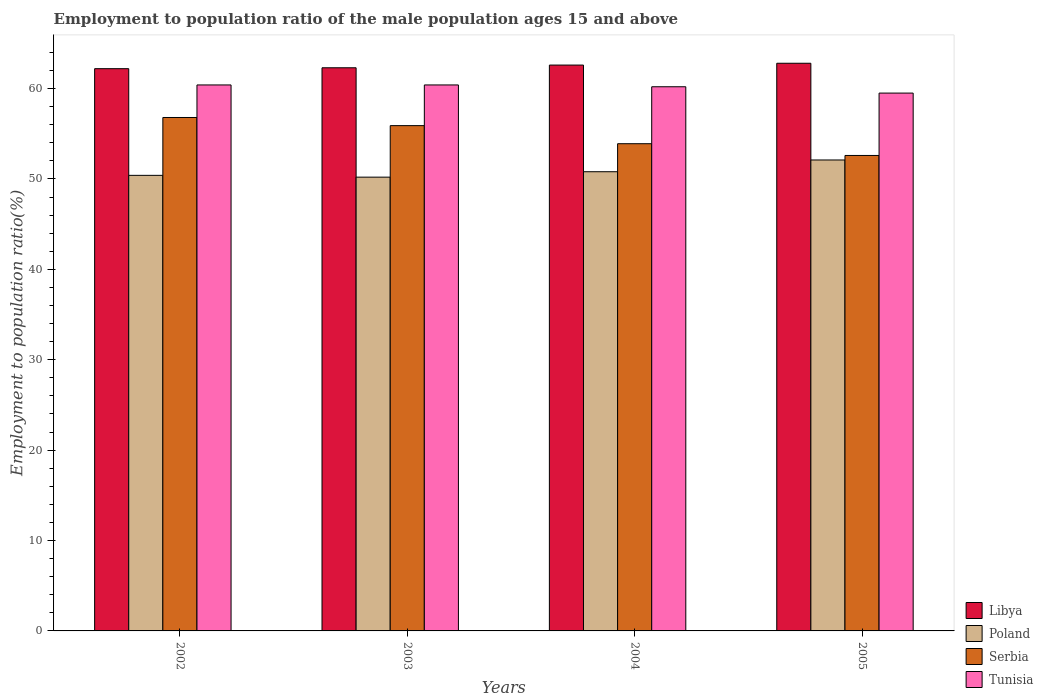How many groups of bars are there?
Offer a terse response. 4. Are the number of bars per tick equal to the number of legend labels?
Make the answer very short. Yes. Are the number of bars on each tick of the X-axis equal?
Provide a short and direct response. Yes. What is the label of the 4th group of bars from the left?
Your response must be concise. 2005. What is the employment to population ratio in Tunisia in 2004?
Offer a very short reply. 60.2. Across all years, what is the maximum employment to population ratio in Tunisia?
Your answer should be very brief. 60.4. Across all years, what is the minimum employment to population ratio in Serbia?
Give a very brief answer. 52.6. What is the total employment to population ratio in Tunisia in the graph?
Your answer should be compact. 240.5. What is the difference between the employment to population ratio in Serbia in 2002 and that in 2005?
Provide a succinct answer. 4.2. What is the difference between the employment to population ratio in Libya in 2002 and the employment to population ratio in Tunisia in 2004?
Give a very brief answer. 2. What is the average employment to population ratio in Libya per year?
Ensure brevity in your answer.  62.47. In the year 2004, what is the difference between the employment to population ratio in Libya and employment to population ratio in Tunisia?
Provide a short and direct response. 2.4. In how many years, is the employment to population ratio in Serbia greater than 62 %?
Make the answer very short. 0. What is the ratio of the employment to population ratio in Serbia in 2003 to that in 2004?
Keep it short and to the point. 1.04. Is the employment to population ratio in Libya in 2002 less than that in 2005?
Provide a succinct answer. Yes. Is the difference between the employment to population ratio in Libya in 2002 and 2005 greater than the difference between the employment to population ratio in Tunisia in 2002 and 2005?
Give a very brief answer. No. What is the difference between the highest and the lowest employment to population ratio in Tunisia?
Offer a very short reply. 0.9. In how many years, is the employment to population ratio in Poland greater than the average employment to population ratio in Poland taken over all years?
Offer a terse response. 1. Is the sum of the employment to population ratio in Libya in 2002 and 2004 greater than the maximum employment to population ratio in Tunisia across all years?
Make the answer very short. Yes. What does the 2nd bar from the left in 2005 represents?
Keep it short and to the point. Poland. What does the 2nd bar from the right in 2002 represents?
Your answer should be very brief. Serbia. How many bars are there?
Offer a terse response. 16. Are all the bars in the graph horizontal?
Your response must be concise. No. How many years are there in the graph?
Provide a short and direct response. 4. Are the values on the major ticks of Y-axis written in scientific E-notation?
Your answer should be compact. No. Does the graph contain any zero values?
Ensure brevity in your answer.  No. Does the graph contain grids?
Your answer should be very brief. No. How are the legend labels stacked?
Offer a very short reply. Vertical. What is the title of the graph?
Provide a succinct answer. Employment to population ratio of the male population ages 15 and above. Does "Finland" appear as one of the legend labels in the graph?
Provide a succinct answer. No. What is the label or title of the X-axis?
Give a very brief answer. Years. What is the label or title of the Y-axis?
Give a very brief answer. Employment to population ratio(%). What is the Employment to population ratio(%) in Libya in 2002?
Your response must be concise. 62.2. What is the Employment to population ratio(%) in Poland in 2002?
Ensure brevity in your answer.  50.4. What is the Employment to population ratio(%) of Serbia in 2002?
Make the answer very short. 56.8. What is the Employment to population ratio(%) of Tunisia in 2002?
Make the answer very short. 60.4. What is the Employment to population ratio(%) in Libya in 2003?
Ensure brevity in your answer.  62.3. What is the Employment to population ratio(%) of Poland in 2003?
Make the answer very short. 50.2. What is the Employment to population ratio(%) of Serbia in 2003?
Ensure brevity in your answer.  55.9. What is the Employment to population ratio(%) of Tunisia in 2003?
Provide a short and direct response. 60.4. What is the Employment to population ratio(%) in Libya in 2004?
Your answer should be compact. 62.6. What is the Employment to population ratio(%) of Poland in 2004?
Offer a very short reply. 50.8. What is the Employment to population ratio(%) in Serbia in 2004?
Offer a terse response. 53.9. What is the Employment to population ratio(%) of Tunisia in 2004?
Offer a terse response. 60.2. What is the Employment to population ratio(%) in Libya in 2005?
Your answer should be compact. 62.8. What is the Employment to population ratio(%) in Poland in 2005?
Make the answer very short. 52.1. What is the Employment to population ratio(%) in Serbia in 2005?
Offer a terse response. 52.6. What is the Employment to population ratio(%) of Tunisia in 2005?
Provide a short and direct response. 59.5. Across all years, what is the maximum Employment to population ratio(%) in Libya?
Offer a very short reply. 62.8. Across all years, what is the maximum Employment to population ratio(%) of Poland?
Your answer should be very brief. 52.1. Across all years, what is the maximum Employment to population ratio(%) of Serbia?
Offer a terse response. 56.8. Across all years, what is the maximum Employment to population ratio(%) of Tunisia?
Provide a succinct answer. 60.4. Across all years, what is the minimum Employment to population ratio(%) in Libya?
Your response must be concise. 62.2. Across all years, what is the minimum Employment to population ratio(%) in Poland?
Give a very brief answer. 50.2. Across all years, what is the minimum Employment to population ratio(%) of Serbia?
Offer a terse response. 52.6. Across all years, what is the minimum Employment to population ratio(%) in Tunisia?
Make the answer very short. 59.5. What is the total Employment to population ratio(%) of Libya in the graph?
Your answer should be compact. 249.9. What is the total Employment to population ratio(%) of Poland in the graph?
Your response must be concise. 203.5. What is the total Employment to population ratio(%) in Serbia in the graph?
Keep it short and to the point. 219.2. What is the total Employment to population ratio(%) of Tunisia in the graph?
Make the answer very short. 240.5. What is the difference between the Employment to population ratio(%) of Poland in 2002 and that in 2003?
Keep it short and to the point. 0.2. What is the difference between the Employment to population ratio(%) of Libya in 2002 and that in 2004?
Provide a short and direct response. -0.4. What is the difference between the Employment to population ratio(%) in Libya in 2002 and that in 2005?
Your response must be concise. -0.6. What is the difference between the Employment to population ratio(%) of Poland in 2002 and that in 2005?
Make the answer very short. -1.7. What is the difference between the Employment to population ratio(%) in Libya in 2003 and that in 2004?
Offer a terse response. -0.3. What is the difference between the Employment to population ratio(%) in Poland in 2003 and that in 2004?
Provide a short and direct response. -0.6. What is the difference between the Employment to population ratio(%) of Libya in 2003 and that in 2005?
Provide a succinct answer. -0.5. What is the difference between the Employment to population ratio(%) in Poland in 2003 and that in 2005?
Your answer should be very brief. -1.9. What is the difference between the Employment to population ratio(%) of Serbia in 2003 and that in 2005?
Provide a short and direct response. 3.3. What is the difference between the Employment to population ratio(%) in Libya in 2002 and the Employment to population ratio(%) in Poland in 2003?
Give a very brief answer. 12. What is the difference between the Employment to population ratio(%) of Libya in 2002 and the Employment to population ratio(%) of Serbia in 2003?
Offer a terse response. 6.3. What is the difference between the Employment to population ratio(%) in Libya in 2002 and the Employment to population ratio(%) in Tunisia in 2003?
Provide a short and direct response. 1.8. What is the difference between the Employment to population ratio(%) of Serbia in 2002 and the Employment to population ratio(%) of Tunisia in 2003?
Keep it short and to the point. -3.6. What is the difference between the Employment to population ratio(%) of Libya in 2002 and the Employment to population ratio(%) of Poland in 2004?
Give a very brief answer. 11.4. What is the difference between the Employment to population ratio(%) of Libya in 2002 and the Employment to population ratio(%) of Tunisia in 2004?
Keep it short and to the point. 2. What is the difference between the Employment to population ratio(%) in Serbia in 2002 and the Employment to population ratio(%) in Tunisia in 2004?
Make the answer very short. -3.4. What is the difference between the Employment to population ratio(%) of Libya in 2002 and the Employment to population ratio(%) of Serbia in 2005?
Provide a succinct answer. 9.6. What is the difference between the Employment to population ratio(%) in Libya in 2002 and the Employment to population ratio(%) in Tunisia in 2005?
Provide a short and direct response. 2.7. What is the difference between the Employment to population ratio(%) in Libya in 2003 and the Employment to population ratio(%) in Serbia in 2004?
Your response must be concise. 8.4. What is the difference between the Employment to population ratio(%) in Libya in 2003 and the Employment to population ratio(%) in Tunisia in 2004?
Offer a terse response. 2.1. What is the difference between the Employment to population ratio(%) in Poland in 2003 and the Employment to population ratio(%) in Serbia in 2004?
Provide a short and direct response. -3.7. What is the difference between the Employment to population ratio(%) in Poland in 2003 and the Employment to population ratio(%) in Tunisia in 2004?
Provide a short and direct response. -10. What is the difference between the Employment to population ratio(%) in Serbia in 2003 and the Employment to population ratio(%) in Tunisia in 2004?
Provide a short and direct response. -4.3. What is the difference between the Employment to population ratio(%) in Libya in 2003 and the Employment to population ratio(%) in Tunisia in 2005?
Your response must be concise. 2.8. What is the difference between the Employment to population ratio(%) in Poland in 2003 and the Employment to population ratio(%) in Serbia in 2005?
Your response must be concise. -2.4. What is the difference between the Employment to population ratio(%) in Poland in 2003 and the Employment to population ratio(%) in Tunisia in 2005?
Give a very brief answer. -9.3. What is the difference between the Employment to population ratio(%) in Libya in 2004 and the Employment to population ratio(%) in Poland in 2005?
Offer a very short reply. 10.5. What is the difference between the Employment to population ratio(%) in Libya in 2004 and the Employment to population ratio(%) in Serbia in 2005?
Provide a short and direct response. 10. What is the difference between the Employment to population ratio(%) in Serbia in 2004 and the Employment to population ratio(%) in Tunisia in 2005?
Your answer should be compact. -5.6. What is the average Employment to population ratio(%) in Libya per year?
Ensure brevity in your answer.  62.48. What is the average Employment to population ratio(%) of Poland per year?
Your response must be concise. 50.88. What is the average Employment to population ratio(%) in Serbia per year?
Provide a short and direct response. 54.8. What is the average Employment to population ratio(%) in Tunisia per year?
Your response must be concise. 60.12. In the year 2002, what is the difference between the Employment to population ratio(%) in Libya and Employment to population ratio(%) in Tunisia?
Provide a short and direct response. 1.8. In the year 2002, what is the difference between the Employment to population ratio(%) of Poland and Employment to population ratio(%) of Tunisia?
Make the answer very short. -10. In the year 2002, what is the difference between the Employment to population ratio(%) in Serbia and Employment to population ratio(%) in Tunisia?
Offer a very short reply. -3.6. In the year 2003, what is the difference between the Employment to population ratio(%) of Libya and Employment to population ratio(%) of Poland?
Give a very brief answer. 12.1. In the year 2003, what is the difference between the Employment to population ratio(%) in Libya and Employment to population ratio(%) in Serbia?
Your response must be concise. 6.4. In the year 2003, what is the difference between the Employment to population ratio(%) of Libya and Employment to population ratio(%) of Tunisia?
Your answer should be compact. 1.9. In the year 2003, what is the difference between the Employment to population ratio(%) of Poland and Employment to population ratio(%) of Tunisia?
Offer a terse response. -10.2. In the year 2004, what is the difference between the Employment to population ratio(%) in Libya and Employment to population ratio(%) in Serbia?
Offer a very short reply. 8.7. In the year 2004, what is the difference between the Employment to population ratio(%) in Libya and Employment to population ratio(%) in Tunisia?
Make the answer very short. 2.4. In the year 2005, what is the difference between the Employment to population ratio(%) of Libya and Employment to population ratio(%) of Poland?
Offer a terse response. 10.7. What is the ratio of the Employment to population ratio(%) of Poland in 2002 to that in 2003?
Make the answer very short. 1. What is the ratio of the Employment to population ratio(%) of Serbia in 2002 to that in 2003?
Your answer should be very brief. 1.02. What is the ratio of the Employment to population ratio(%) in Tunisia in 2002 to that in 2003?
Your answer should be very brief. 1. What is the ratio of the Employment to population ratio(%) of Poland in 2002 to that in 2004?
Offer a very short reply. 0.99. What is the ratio of the Employment to population ratio(%) in Serbia in 2002 to that in 2004?
Give a very brief answer. 1.05. What is the ratio of the Employment to population ratio(%) of Tunisia in 2002 to that in 2004?
Keep it short and to the point. 1. What is the ratio of the Employment to population ratio(%) of Libya in 2002 to that in 2005?
Keep it short and to the point. 0.99. What is the ratio of the Employment to population ratio(%) of Poland in 2002 to that in 2005?
Provide a short and direct response. 0.97. What is the ratio of the Employment to population ratio(%) of Serbia in 2002 to that in 2005?
Provide a succinct answer. 1.08. What is the ratio of the Employment to population ratio(%) in Tunisia in 2002 to that in 2005?
Ensure brevity in your answer.  1.02. What is the ratio of the Employment to population ratio(%) in Libya in 2003 to that in 2004?
Your answer should be compact. 1. What is the ratio of the Employment to population ratio(%) of Poland in 2003 to that in 2004?
Your answer should be compact. 0.99. What is the ratio of the Employment to population ratio(%) of Serbia in 2003 to that in 2004?
Your response must be concise. 1.04. What is the ratio of the Employment to population ratio(%) of Tunisia in 2003 to that in 2004?
Ensure brevity in your answer.  1. What is the ratio of the Employment to population ratio(%) in Libya in 2003 to that in 2005?
Offer a terse response. 0.99. What is the ratio of the Employment to population ratio(%) of Poland in 2003 to that in 2005?
Ensure brevity in your answer.  0.96. What is the ratio of the Employment to population ratio(%) in Serbia in 2003 to that in 2005?
Provide a succinct answer. 1.06. What is the ratio of the Employment to population ratio(%) in Tunisia in 2003 to that in 2005?
Ensure brevity in your answer.  1.02. What is the ratio of the Employment to population ratio(%) of Libya in 2004 to that in 2005?
Offer a terse response. 1. What is the ratio of the Employment to population ratio(%) of Poland in 2004 to that in 2005?
Ensure brevity in your answer.  0.97. What is the ratio of the Employment to population ratio(%) in Serbia in 2004 to that in 2005?
Offer a terse response. 1.02. What is the ratio of the Employment to population ratio(%) of Tunisia in 2004 to that in 2005?
Your answer should be very brief. 1.01. What is the difference between the highest and the second highest Employment to population ratio(%) in Tunisia?
Your answer should be compact. 0. What is the difference between the highest and the lowest Employment to population ratio(%) in Tunisia?
Your answer should be compact. 0.9. 